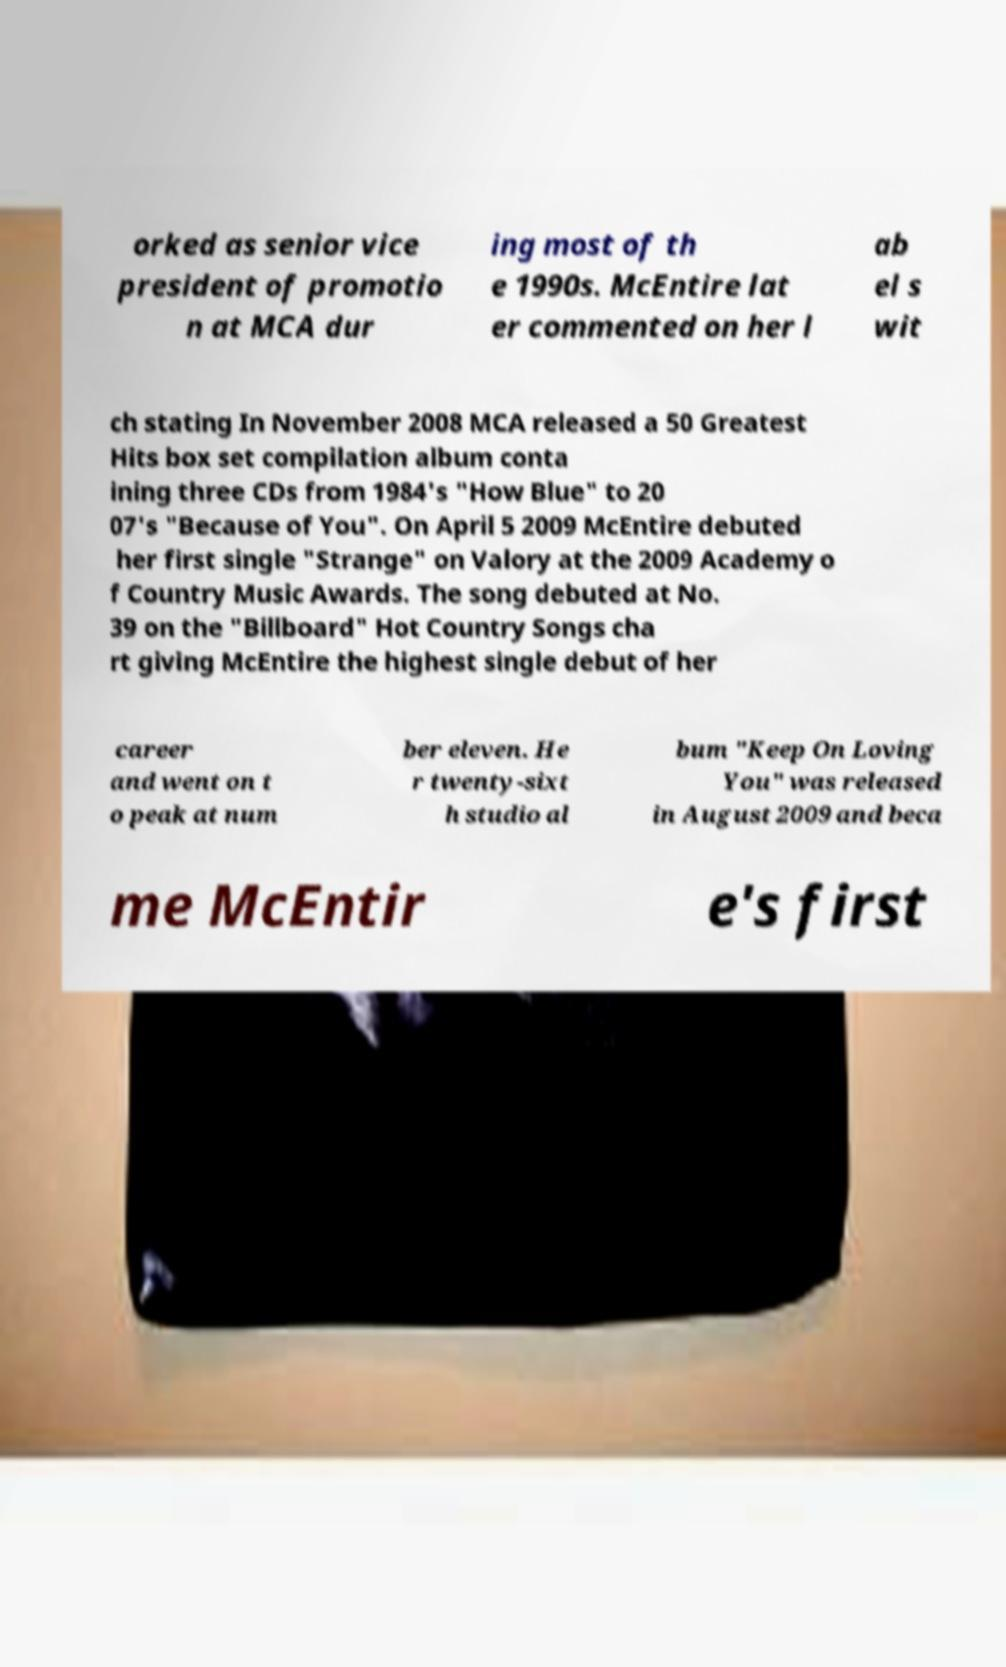Could you assist in decoding the text presented in this image and type it out clearly? orked as senior vice president of promotio n at MCA dur ing most of th e 1990s. McEntire lat er commented on her l ab el s wit ch stating In November 2008 MCA released a 50 Greatest Hits box set compilation album conta ining three CDs from 1984's "How Blue" to 20 07's "Because of You". On April 5 2009 McEntire debuted her first single "Strange" on Valory at the 2009 Academy o f Country Music Awards. The song debuted at No. 39 on the "Billboard" Hot Country Songs cha rt giving McEntire the highest single debut of her career and went on t o peak at num ber eleven. He r twenty-sixt h studio al bum "Keep On Loving You" was released in August 2009 and beca me McEntir e's first 